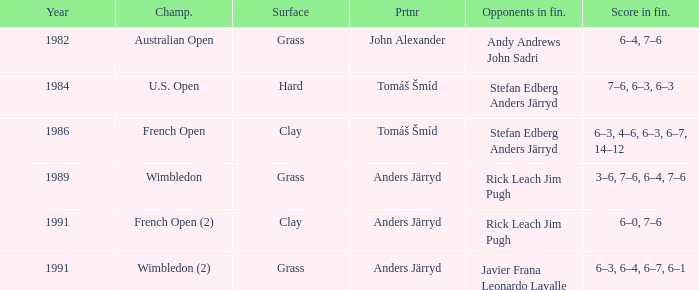Could you parse the entire table? {'header': ['Year', 'Champ.', 'Surface', 'Prtnr', 'Opponents in fin.', 'Score in fin.'], 'rows': [['1982', 'Australian Open', 'Grass', 'John Alexander', 'Andy Andrews John Sadri', '6–4, 7–6'], ['1984', 'U.S. Open', 'Hard', 'Tomáš Šmíd', 'Stefan Edberg Anders Järryd', '7–6, 6–3, 6–3'], ['1986', 'French Open', 'Clay', 'Tomáš Šmíd', 'Stefan Edberg Anders Järryd', '6–3, 4–6, 6–3, 6–7, 14–12'], ['1989', 'Wimbledon', 'Grass', 'Anders Järryd', 'Rick Leach Jim Pugh', '3–6, 7–6, 6–4, 7–6'], ['1991', 'French Open (2)', 'Clay', 'Anders Järryd', 'Rick Leach Jim Pugh', '6–0, 7–6'], ['1991', 'Wimbledon (2)', 'Grass', 'Anders Järryd', 'Javier Frana Leonardo Lavalle', '6–3, 6–4, 6–7, 6–1']]} What was the surface when he played with John Alexander?  Grass. 